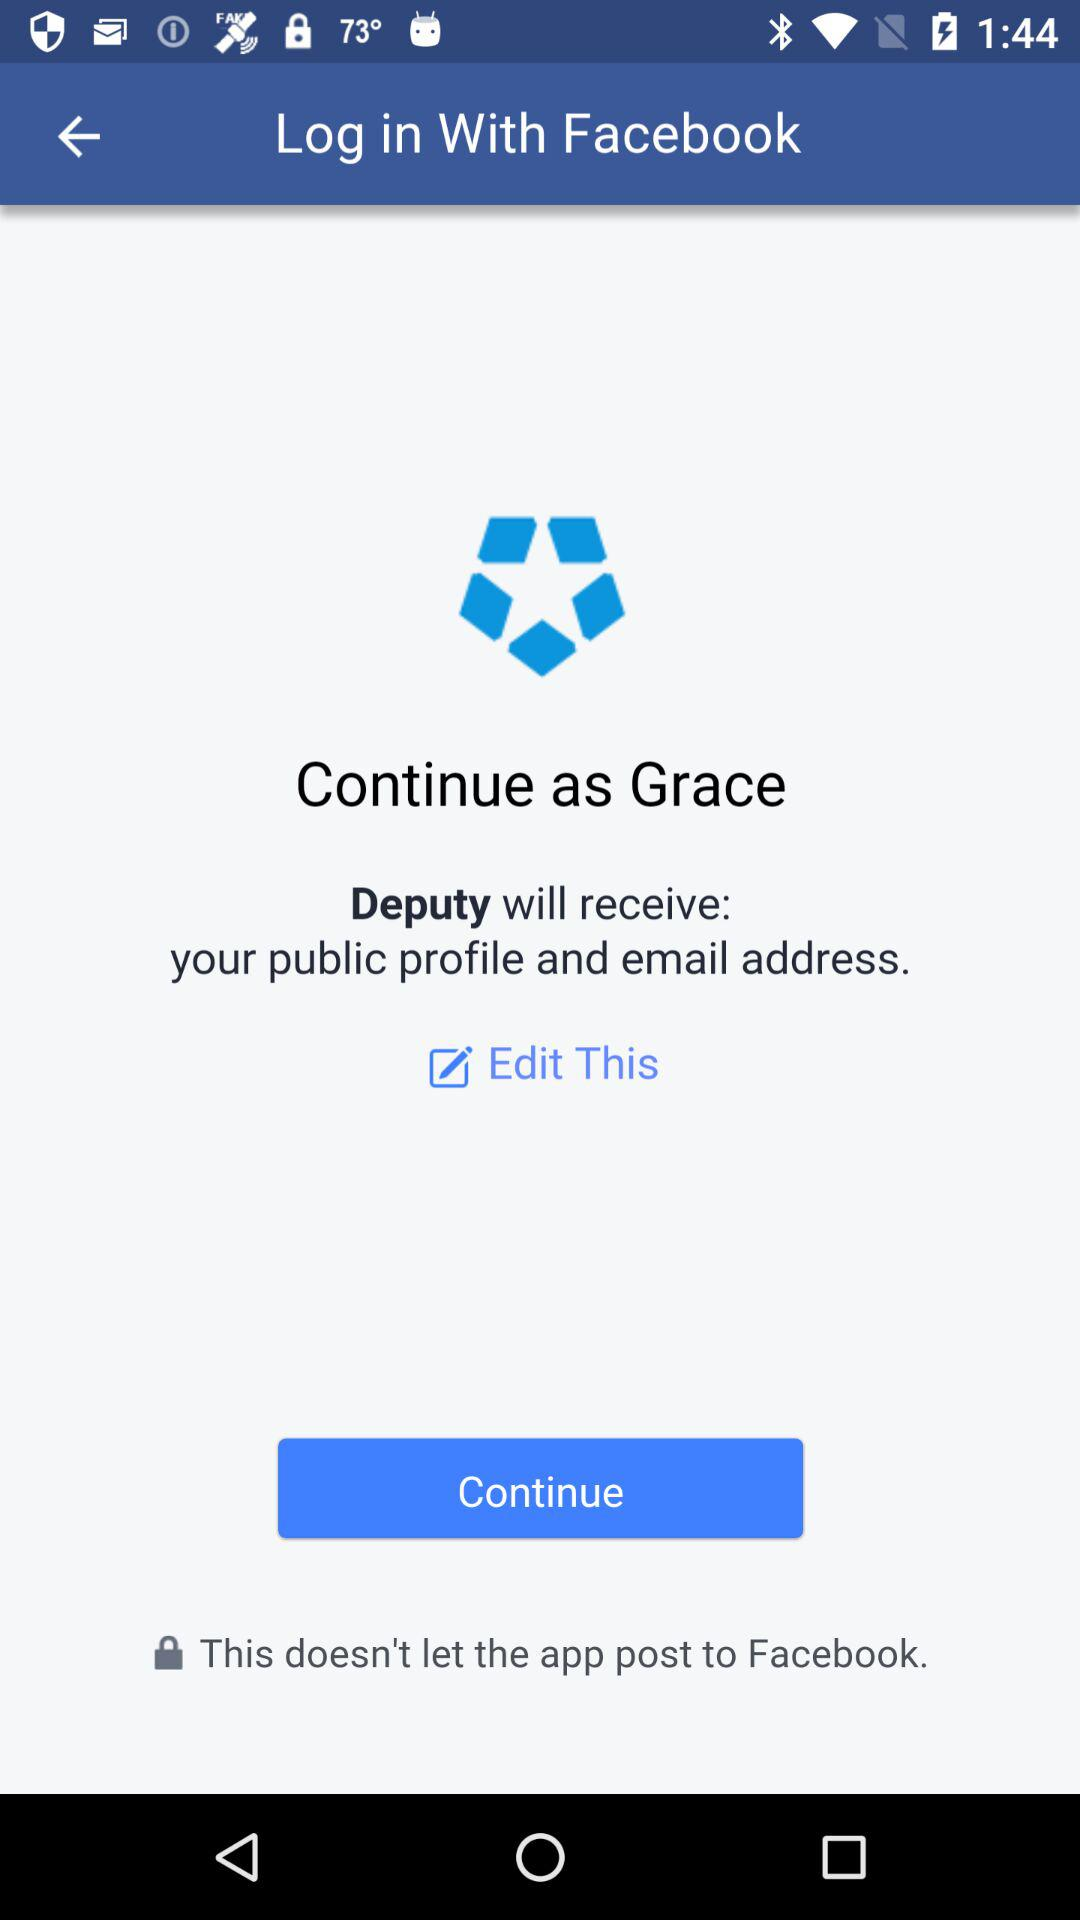Through what application can we log in? You can log in through "Facebook". 